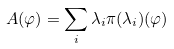<formula> <loc_0><loc_0><loc_500><loc_500>A ( \varphi ) = \sum _ { i } \lambda _ { i } \pi ( { \lambda _ { i } } ) ( \varphi )</formula> 